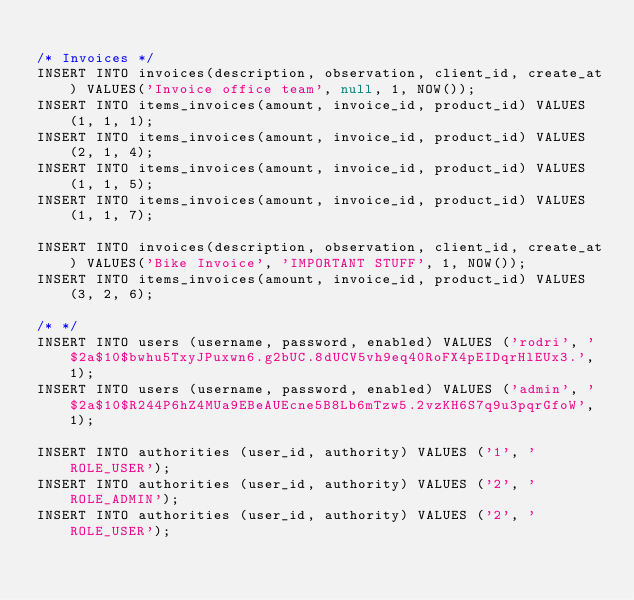Convert code to text. <code><loc_0><loc_0><loc_500><loc_500><_SQL_>
/* Invoices */
INSERT INTO invoices(description, observation, client_id, create_at) VALUES('Invoice office team', null, 1, NOW());
INSERT INTO items_invoices(amount, invoice_id, product_id) VALUES(1, 1, 1); 
INSERT INTO items_invoices(amount, invoice_id, product_id) VALUES(2, 1, 4); 
INSERT INTO items_invoices(amount, invoice_id, product_id) VALUES(1, 1, 5); 
INSERT INTO items_invoices(amount, invoice_id, product_id) VALUES(1, 1, 7); 

INSERT INTO invoices(description, observation, client_id, create_at) VALUES('Bike Invoice', 'IMPORTANT STUFF', 1, NOW());
INSERT INTO items_invoices(amount, invoice_id, product_id) VALUES(3, 2, 6); 

/* */
INSERT INTO users (username, password, enabled) VALUES ('rodri', '$2a$10$bwhu5TxyJPuxwn6.g2bUC.8dUCV5vh9eq40RoFX4pEIDqrHlEUx3.', 1);
INSERT INTO users (username, password, enabled) VALUES ('admin', '$2a$10$R244P6hZ4MUa9EBeAUEcne5B8Lb6mTzw5.2vzKH6S7q9u3pqrGfoW', 1);

INSERT INTO authorities (user_id, authority) VALUES ('1', 'ROLE_USER');
INSERT INTO authorities (user_id, authority) VALUES ('2', 'ROLE_ADMIN');
INSERT INTO authorities (user_id, authority) VALUES ('2', 'ROLE_USER');
</code> 